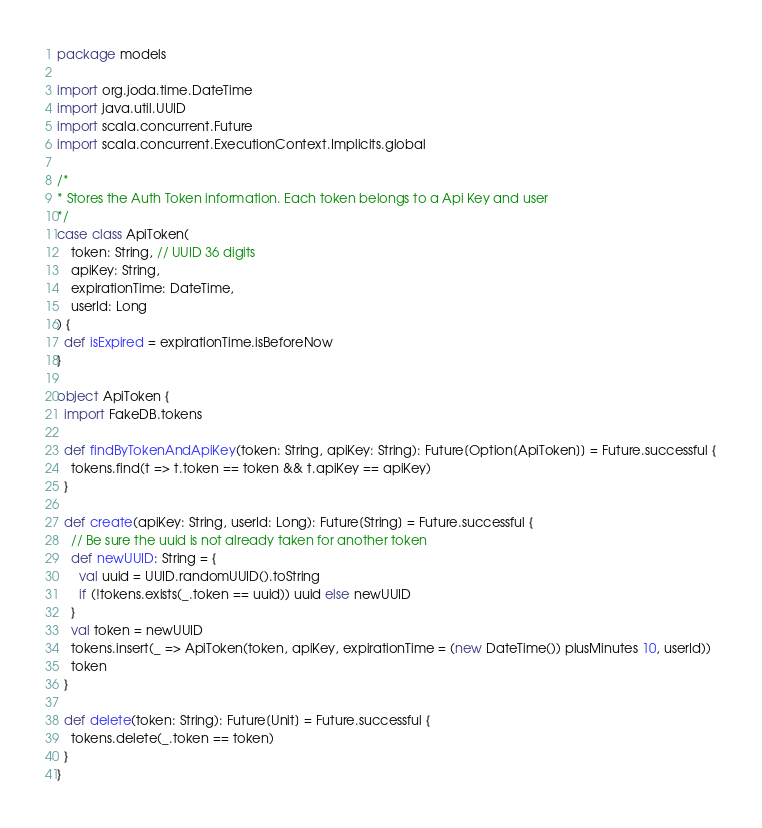<code> <loc_0><loc_0><loc_500><loc_500><_Scala_>package models

import org.joda.time.DateTime
import java.util.UUID
import scala.concurrent.Future
import scala.concurrent.ExecutionContext.Implicits.global

/*
* Stores the Auth Token information. Each token belongs to a Api Key and user
*/
case class ApiToken(
    token: String, // UUID 36 digits
    apiKey: String,
    expirationTime: DateTime,
    userId: Long
) {
  def isExpired = expirationTime.isBeforeNow
}

object ApiToken {
  import FakeDB.tokens

  def findByTokenAndApiKey(token: String, apiKey: String): Future[Option[ApiToken]] = Future.successful {
    tokens.find(t => t.token == token && t.apiKey == apiKey)
  }

  def create(apiKey: String, userId: Long): Future[String] = Future.successful {
    // Be sure the uuid is not already taken for another token
    def newUUID: String = {
      val uuid = UUID.randomUUID().toString
      if (!tokens.exists(_.token == uuid)) uuid else newUUID
    }
    val token = newUUID
    tokens.insert(_ => ApiToken(token, apiKey, expirationTime = (new DateTime()) plusMinutes 10, userId))
    token
  }

  def delete(token: String): Future[Unit] = Future.successful {
    tokens.delete(_.token == token)
  }
}
</code> 